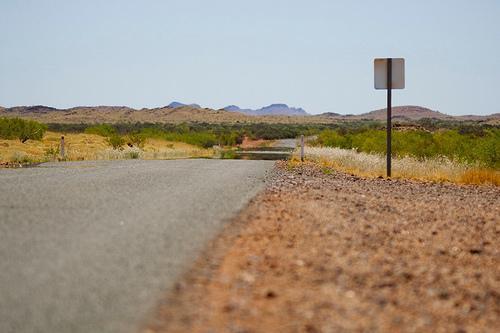How many signs are there?
Give a very brief answer. 1. 